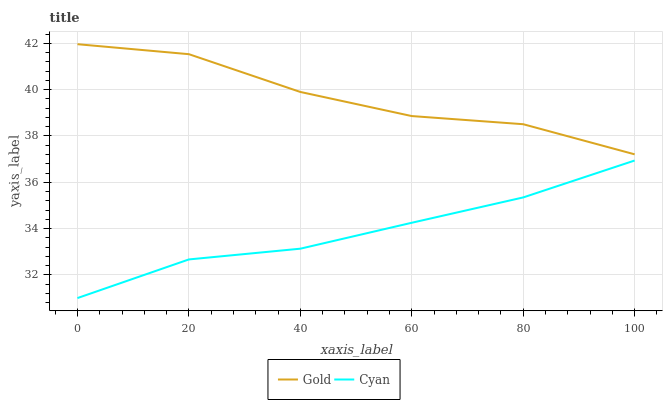Does Cyan have the minimum area under the curve?
Answer yes or no. Yes. Does Gold have the maximum area under the curve?
Answer yes or no. Yes. Does Gold have the minimum area under the curve?
Answer yes or no. No. Is Cyan the smoothest?
Answer yes or no. Yes. Is Gold the roughest?
Answer yes or no. Yes. Is Gold the smoothest?
Answer yes or no. No. Does Cyan have the lowest value?
Answer yes or no. Yes. Does Gold have the lowest value?
Answer yes or no. No. Does Gold have the highest value?
Answer yes or no. Yes. Is Cyan less than Gold?
Answer yes or no. Yes. Is Gold greater than Cyan?
Answer yes or no. Yes. Does Cyan intersect Gold?
Answer yes or no. No. 